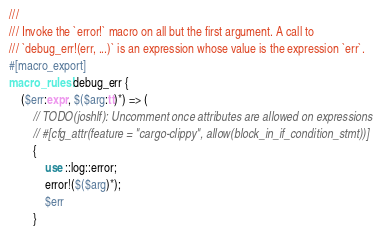<code> <loc_0><loc_0><loc_500><loc_500><_Rust_>///
/// Invoke the `error!` macro on all but the first argument. A call to
/// `debug_err!(err, ...)` is an expression whose value is the expression `err`.
#[macro_export]
macro_rules! debug_err {
    ($err:expr, $($arg:tt)*) => (
        // TODO(joshlf): Uncomment once attributes are allowed on expressions
        // #[cfg_attr(feature = "cargo-clippy", allow(block_in_if_condition_stmt))]
        {
            use ::log::error;
            error!($($arg)*);
            $err
        }</code> 